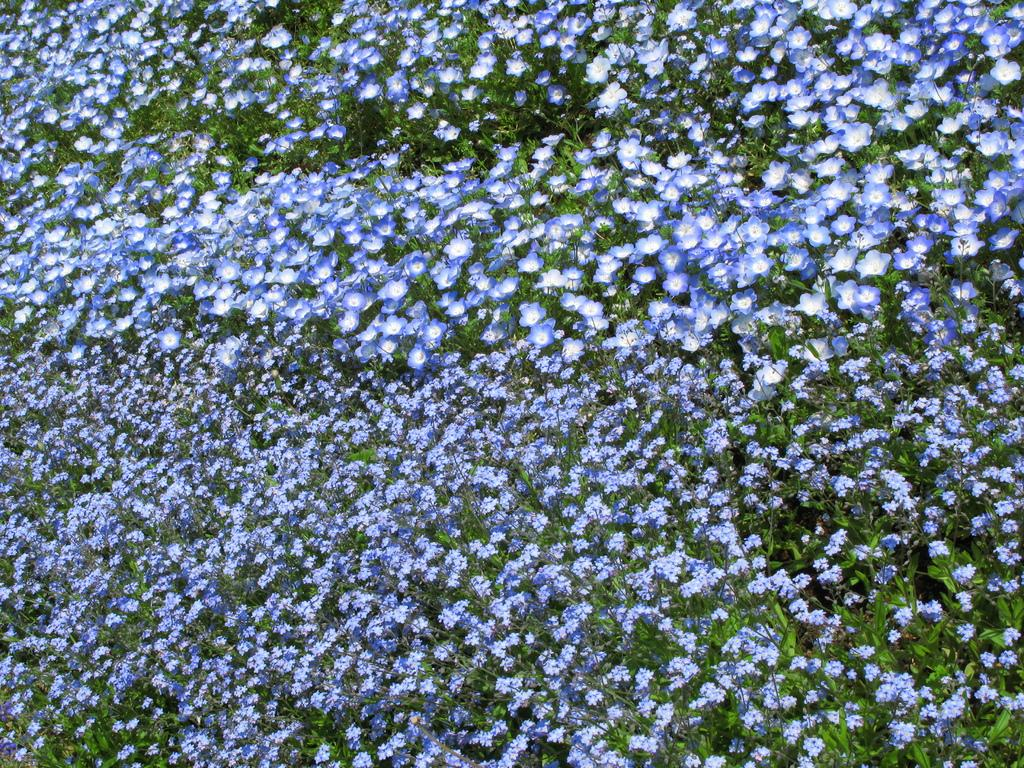What type of living organisms can be seen in the image? Plants can be seen in the image. What specific feature of the plants is visible in the image? The plants have flowers. What type of instrument is being played by the aunt in the image? There is no aunt or instrument present in the image; it only features plants with flowers. 